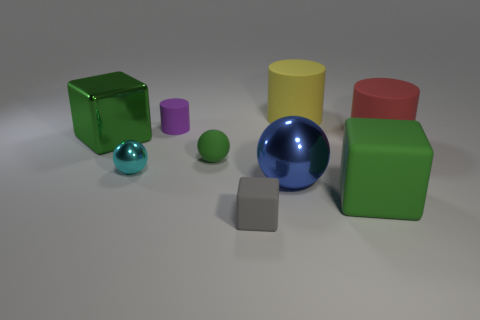There is a gray cube that is made of the same material as the yellow object; what size is it?
Your answer should be compact. Small. Are there any other things of the same color as the large rubber block?
Provide a short and direct response. Yes. Do the blue thing and the cube that is behind the big blue object have the same material?
Your answer should be compact. Yes. There is a yellow thing that is the same shape as the tiny purple rubber thing; what is its material?
Ensure brevity in your answer.  Rubber. Does the cylinder that is right of the big rubber block have the same material as the green block in front of the small metal ball?
Offer a very short reply. Yes. The big rubber cylinder that is behind the small purple matte cylinder that is left of the large block right of the big green shiny cube is what color?
Make the answer very short. Yellow. How many other things are the same shape as the yellow rubber thing?
Make the answer very short. 2. Is the metal cube the same color as the tiny rubber cylinder?
Offer a very short reply. No. What number of things are tiny green cylinders or large cylinders that are in front of the small purple object?
Offer a very short reply. 1. Is there a cyan shiny thing that has the same size as the metallic block?
Your answer should be compact. No. 